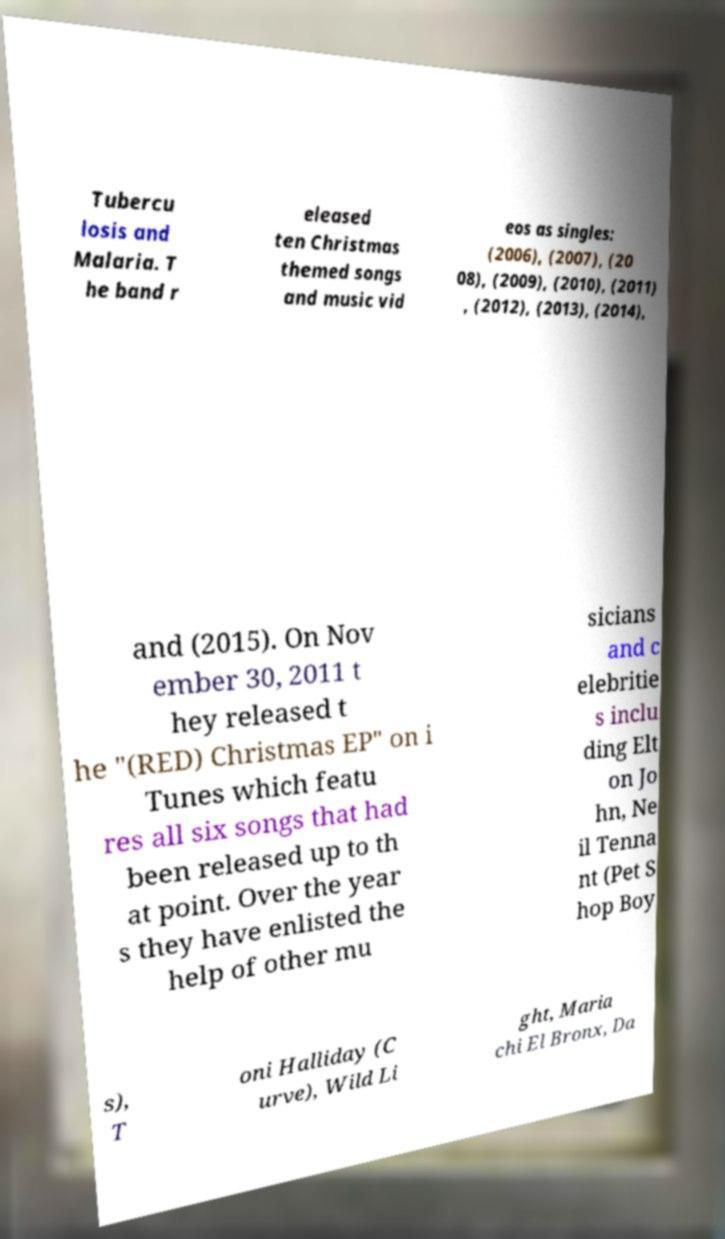What messages or text are displayed in this image? I need them in a readable, typed format. Tubercu losis and Malaria. T he band r eleased ten Christmas themed songs and music vid eos as singles: (2006), (2007), (20 08), (2009), (2010), (2011) , (2012), (2013), (2014), and (2015). On Nov ember 30, 2011 t hey released t he "(RED) Christmas EP" on i Tunes which featu res all six songs that had been released up to th at point. Over the year s they have enlisted the help of other mu sicians and c elebritie s inclu ding Elt on Jo hn, Ne il Tenna nt (Pet S hop Boy s), T oni Halliday (C urve), Wild Li ght, Maria chi El Bronx, Da 